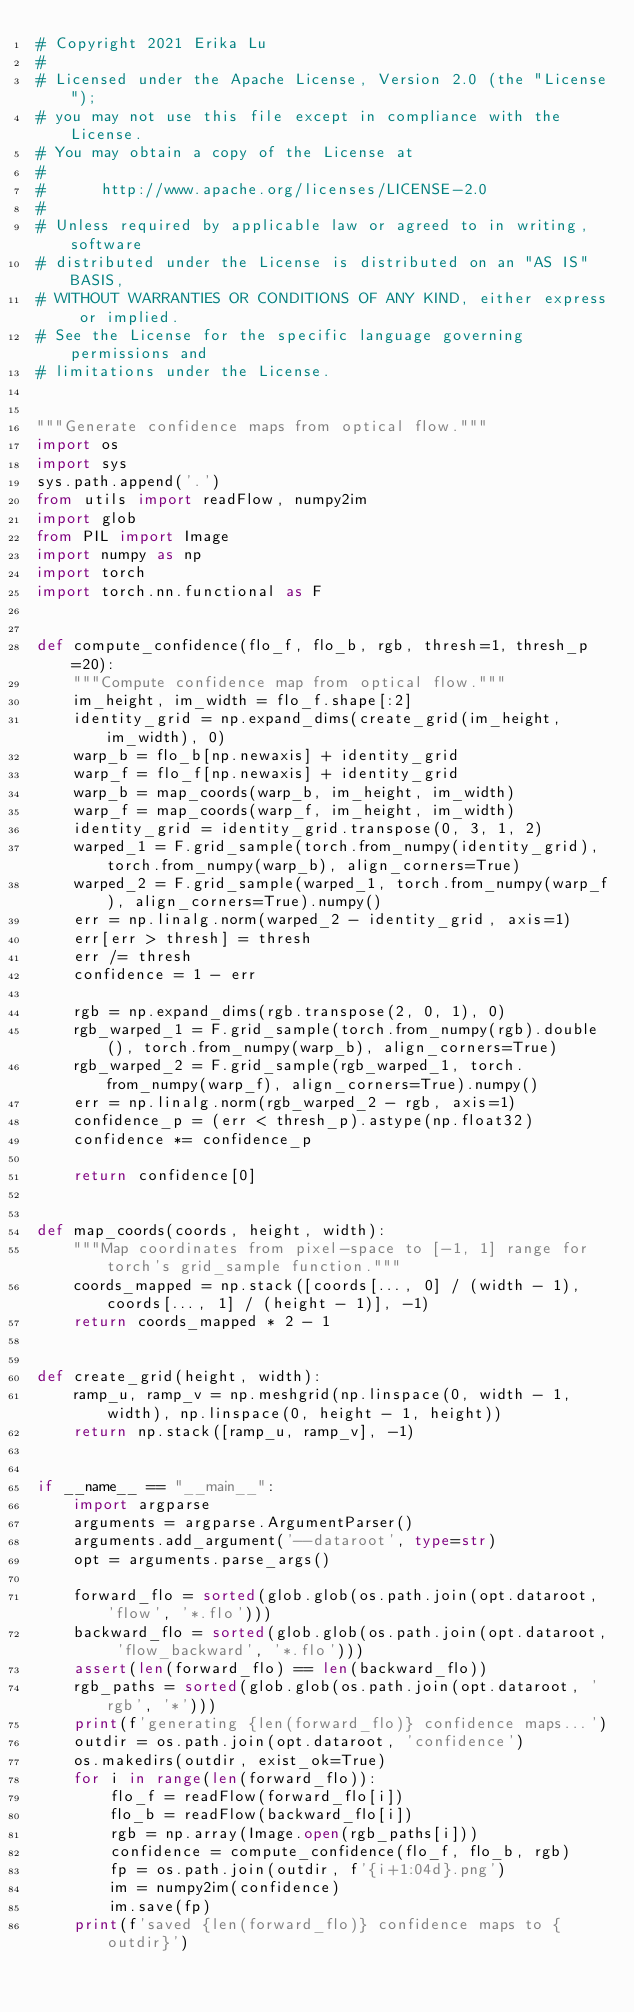<code> <loc_0><loc_0><loc_500><loc_500><_Python_># Copyright 2021 Erika Lu
#
# Licensed under the Apache License, Version 2.0 (the "License");
# you may not use this file except in compliance with the License.
# You may obtain a copy of the License at
#
#      http://www.apache.org/licenses/LICENSE-2.0
#
# Unless required by applicable law or agreed to in writing, software
# distributed under the License is distributed on an "AS IS" BASIS,
# WITHOUT WARRANTIES OR CONDITIONS OF ANY KIND, either express or implied.
# See the License for the specific language governing permissions and
# limitations under the License.


"""Generate confidence maps from optical flow."""
import os
import sys
sys.path.append('.')
from utils import readFlow, numpy2im
import glob
from PIL import Image
import numpy as np
import torch
import torch.nn.functional as F


def compute_confidence(flo_f, flo_b, rgb, thresh=1, thresh_p=20):
    """Compute confidence map from optical flow."""
    im_height, im_width = flo_f.shape[:2]
    identity_grid = np.expand_dims(create_grid(im_height, im_width), 0)
    warp_b = flo_b[np.newaxis] + identity_grid
    warp_f = flo_f[np.newaxis] + identity_grid
    warp_b = map_coords(warp_b, im_height, im_width)
    warp_f = map_coords(warp_f, im_height, im_width)
    identity_grid = identity_grid.transpose(0, 3, 1, 2)
    warped_1 = F.grid_sample(torch.from_numpy(identity_grid), torch.from_numpy(warp_b), align_corners=True)
    warped_2 = F.grid_sample(warped_1, torch.from_numpy(warp_f), align_corners=True).numpy()
    err = np.linalg.norm(warped_2 - identity_grid, axis=1)
    err[err > thresh] = thresh
    err /= thresh
    confidence = 1 - err

    rgb = np.expand_dims(rgb.transpose(2, 0, 1), 0)
    rgb_warped_1 = F.grid_sample(torch.from_numpy(rgb).double(), torch.from_numpy(warp_b), align_corners=True)
    rgb_warped_2 = F.grid_sample(rgb_warped_1, torch.from_numpy(warp_f), align_corners=True).numpy()
    err = np.linalg.norm(rgb_warped_2 - rgb, axis=1)
    confidence_p = (err < thresh_p).astype(np.float32)
    confidence *= confidence_p

    return confidence[0]


def map_coords(coords, height, width):
    """Map coordinates from pixel-space to [-1, 1] range for torch's grid_sample function."""
    coords_mapped = np.stack([coords[..., 0] / (width - 1), coords[..., 1] / (height - 1)], -1)
    return coords_mapped * 2 - 1


def create_grid(height, width):
    ramp_u, ramp_v = np.meshgrid(np.linspace(0, width - 1, width), np.linspace(0, height - 1, height))
    return np.stack([ramp_u, ramp_v], -1)


if __name__ == "__main__":
    import argparse
    arguments = argparse.ArgumentParser()
    arguments.add_argument('--dataroot', type=str)
    opt = arguments.parse_args()

    forward_flo = sorted(glob.glob(os.path.join(opt.dataroot, 'flow', '*.flo')))
    backward_flo = sorted(glob.glob(os.path.join(opt.dataroot, 'flow_backward', '*.flo')))
    assert(len(forward_flo) == len(backward_flo))
    rgb_paths = sorted(glob.glob(os.path.join(opt.dataroot, 'rgb', '*')))
    print(f'generating {len(forward_flo)} confidence maps...')
    outdir = os.path.join(opt.dataroot, 'confidence')
    os.makedirs(outdir, exist_ok=True)
    for i in range(len(forward_flo)):
        flo_f = readFlow(forward_flo[i])
        flo_b = readFlow(backward_flo[i])
        rgb = np.array(Image.open(rgb_paths[i]))
        confidence = compute_confidence(flo_f, flo_b, rgb)
        fp = os.path.join(outdir, f'{i+1:04d}.png')
        im = numpy2im(confidence)
        im.save(fp)
    print(f'saved {len(forward_flo)} confidence maps to {outdir}')
</code> 